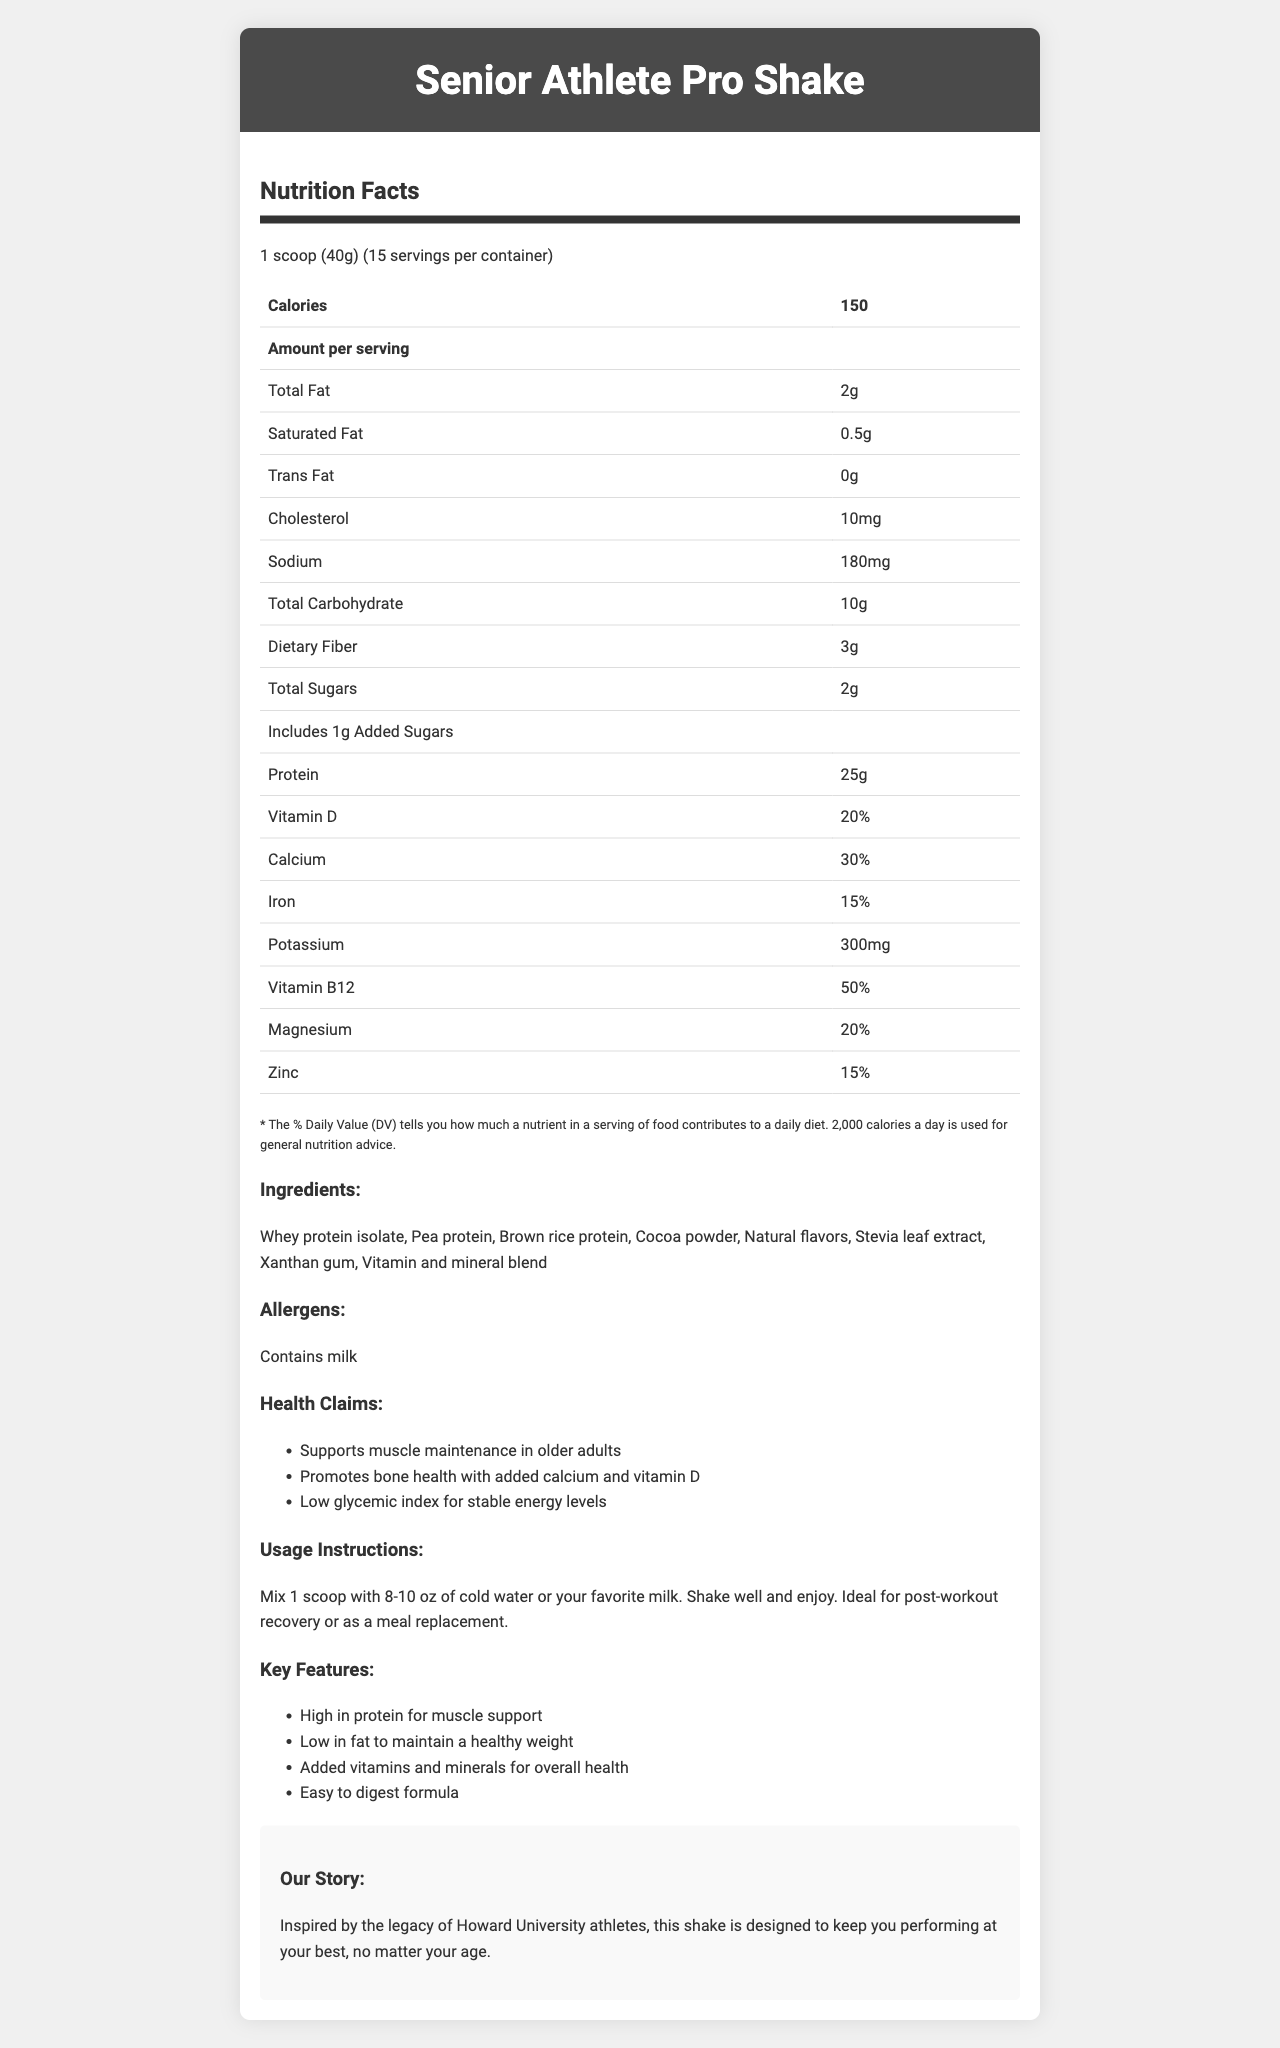what is the serving size? The document states that the serving size is "1 scoop (40g)".
Answer: 1 scoop (40g) how many calories are in one serving? The document indicates that one serving contains 150 calories.
Answer: 150 how much protein is there per serving? The nutrition facts table shows that each serving contains 25 grams of protein.
Answer: 25g what are the allergens present in the product? The document lists "Contains milk" under the allergens section.
Answer: Contains milk which ingredients are listed in the product? The ingredients listed in the document include Whey protein isolate, Pea protein, Brown rice protein, Cocoa powder, Natural flavors, Stevia leaf extract, Xanthan gum, and a Vitamin and mineral blend.
Answer: Whey protein isolate, Pea protein, Brown rice protein, Cocoa powder, Natural flavors, Stevia leaf extract, Xanthan gum, Vitamin and mineral blend how much sodium is in one serving? The nutrition facts table indicates that one serving contains 180mg of sodium.
Answer: 180mg how many grams of total sugars are there in one serving? The document's nutrition facts table states that there are 2 grams of total sugars per serving.
Answer: 2g what are the key features of the product? The document lists the key features as "High in protein for muscle support, Low in fat to maintain a healthy weight, Added vitamins and minerals for overall health, Easy to digest formula".
Answer: High in protein for muscle support, Low in fat to maintain a healthy weight, Added vitamins and minerals for overall health, Easy to digest formula what is the recommended usage instruction for this product? The usage instructions state, "Mix 1 scoop with 8-10 oz of cold water or your favorite milk. Shake well and enjoy. Ideal for post-workout recovery or as a meal replacement."
Answer: Mix 1 scoop with 8-10 oz of cold water or your favorite milk. Shake well and enjoy. Ideal for post-workout recovery or as a meal replacement. who is the target audience for the shake? The target audience mentioned in the document is "Senior athletes and active older adults".
Answer: Senior athletes and active older adults which vitamin is present in the highest percentage of daily value per serving? A. Vitamin D B. Vitamin B12 C. Calcium The document shows that Vitamin B12 is present at 50% of the daily value, which is the highest among the listed vitamins and minerals.
Answer: B. Vitamin B12 what is the amount of cholesterol per serving? A. 5mg B. 10mg C. 15mg D. 20mg The nutrition facts table indicates that each serving contains 10mg of cholesterol.
Answer: B. 10mg does the product support muscle maintenance in older adults? One of the health claims mentioned in the document is "Supports muscle maintenance in older adults".
Answer: Yes summarize the main purpose of the Senior Athlete Pro Shake The Senior Athlete Pro Shake is designed to support the nutritional needs of senior athletes by providing high protein, low fat, and added vitamins and minerals. It promotes muscle maintenance, bone health, and stable energy levels.
Answer: The Senior Athlete Pro Shake is a high-protein, low-fat meal replacement shake designed for senior athletes and active older adults. It supports muscle maintenance, promotes bone health, and ensures stable energy levels with added vitamins and minerals in an easy-to-digest formula. how many servings are there in one container? The document specifies that there are 15 servings per container.
Answer: 15 what is the serving size of this product in grams? The serving size is listed as "1 scoop (40g)".
Answer: 40g what is the brand story behind this product? The brand story explains that the shake is inspired by the legacy of Howard University athletes and aims to help users perform at their best, regardless of age.
Answer: Inspired by the legacy of Howard University athletes, this shake is designed to keep you performing at your best, no matter your age. is this product suitable for vegetarians? The document does not explicitly mention whether the product is suitable for vegetarians. It contains whey protein isolate, which may come from an animal source.
Answer: Cannot be determined 